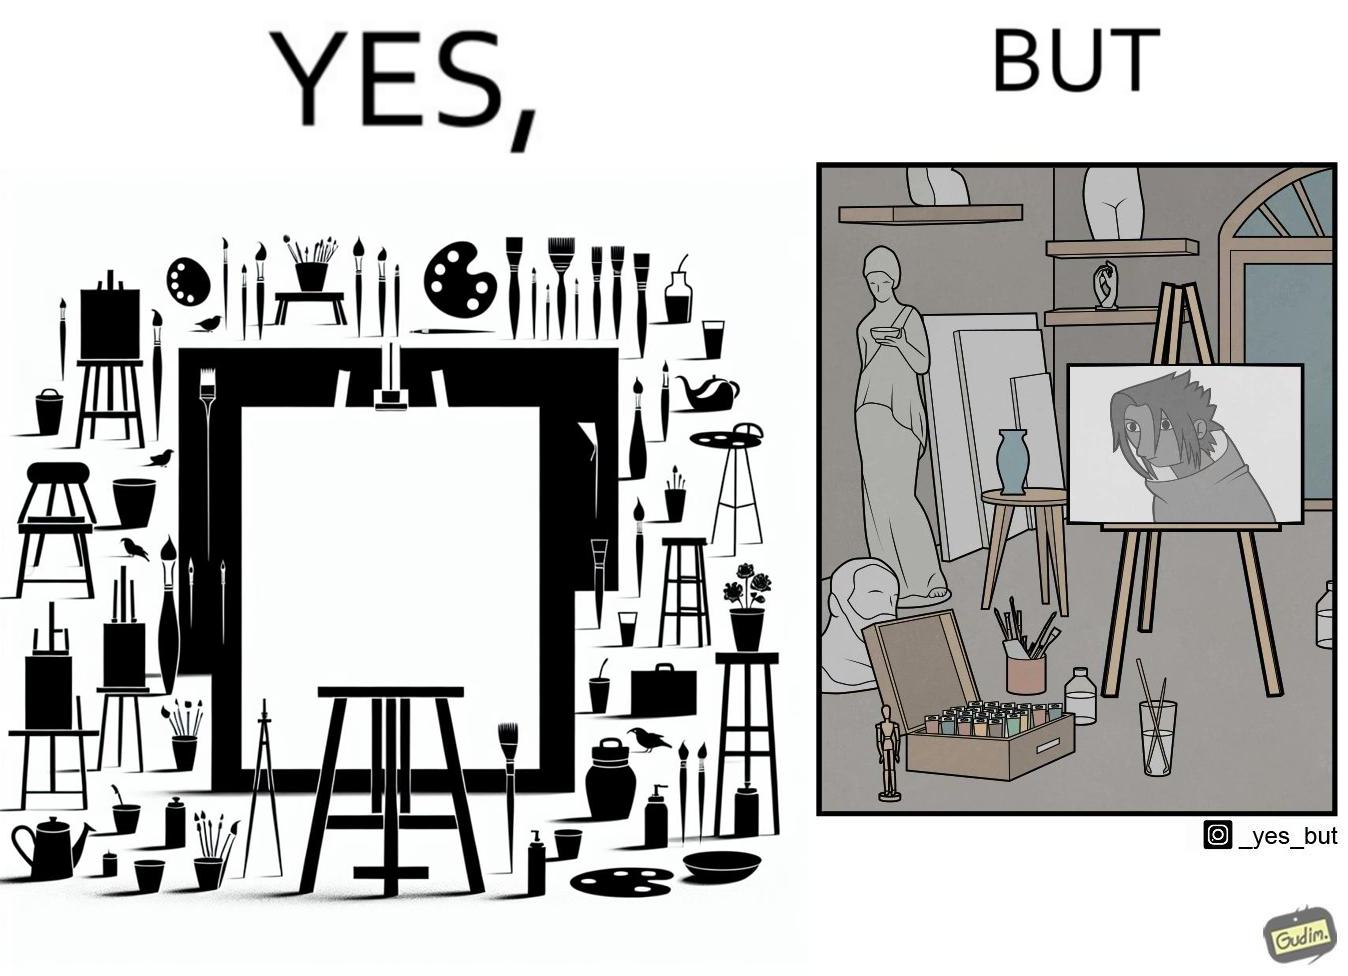What is shown in this image? The image is ironical, as even though the art studio contains a palette of a range of color paints, the painting on the canvas is black and white. 